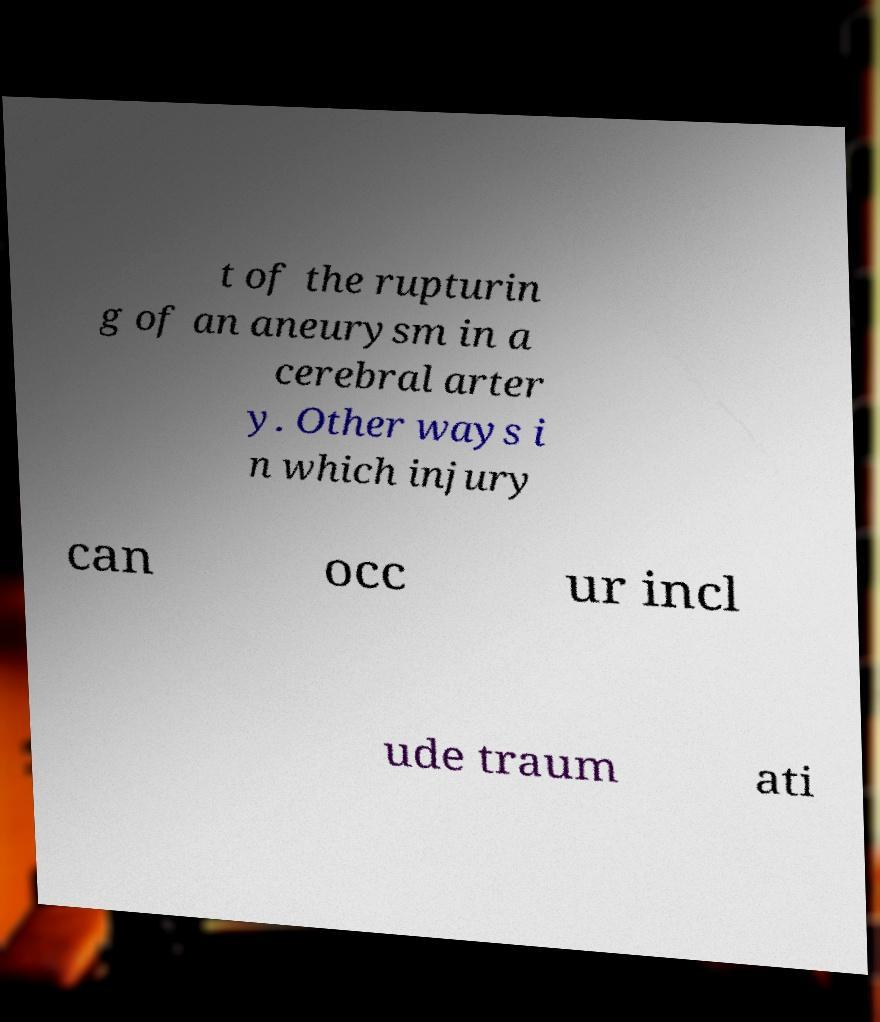I need the written content from this picture converted into text. Can you do that? t of the rupturin g of an aneurysm in a cerebral arter y. Other ways i n which injury can occ ur incl ude traum ati 